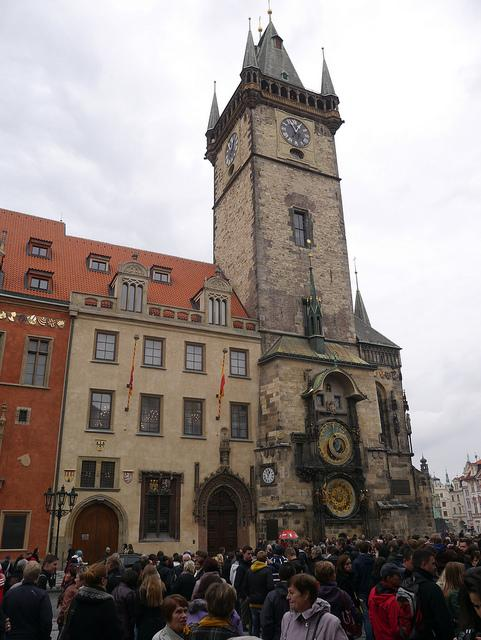What is the black circular object near the top of the tower used for?

Choices:
A) telling time
B) cooking pizza
C) feeding birds
D) looking out telling time 